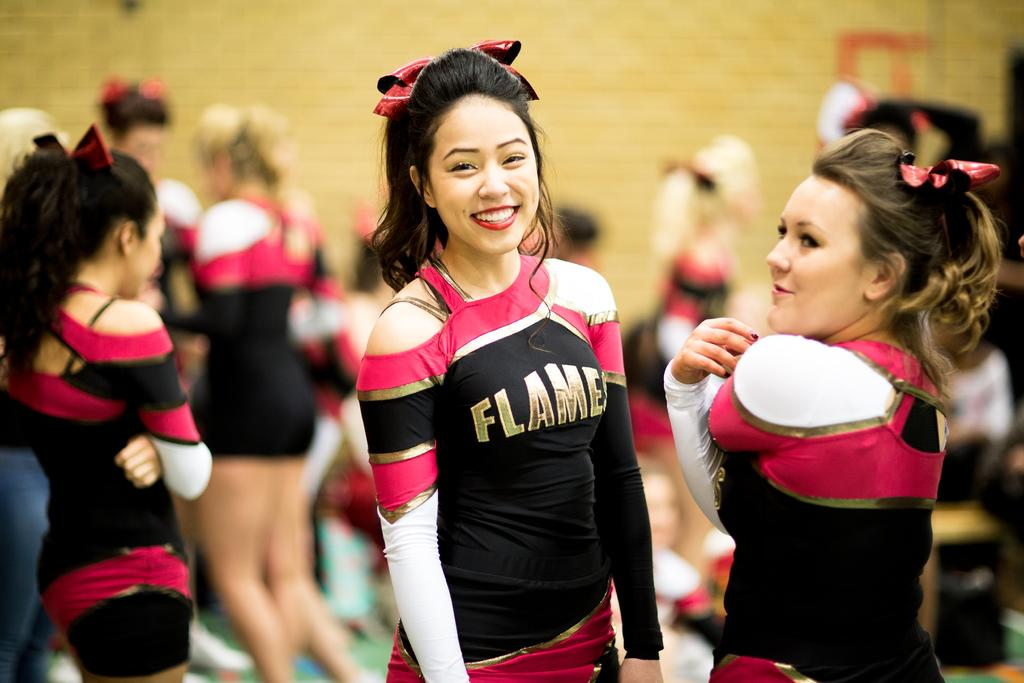<image>
Offer a succinct explanation of the picture presented. cheerleaders for the flames are wearing their uniforma 